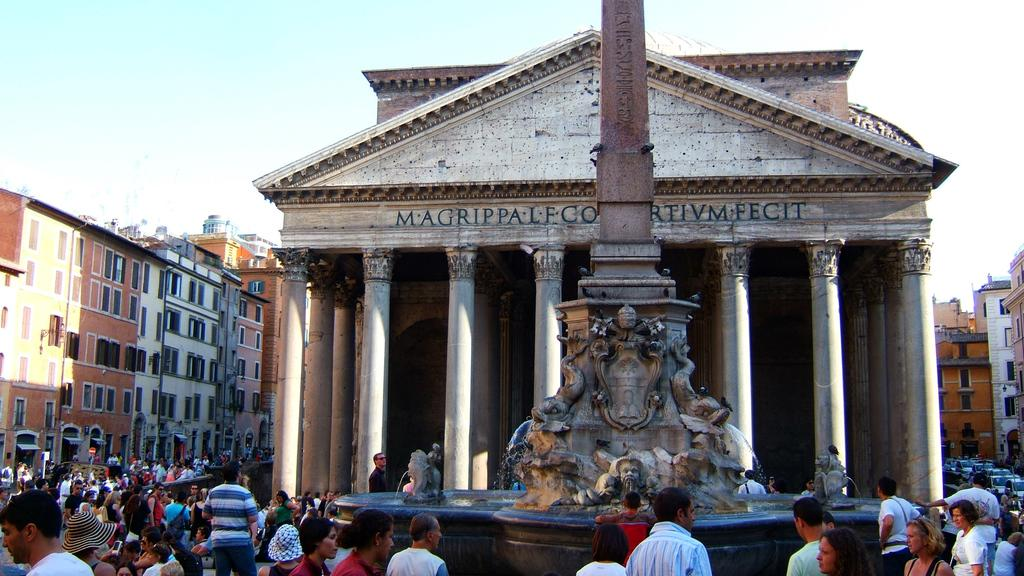What is the main feature in the middle of the image? There is a fountain in the center of the image. What can be seen in the distance behind the fountain? There are buildings in the background of the image. How many people are visible at the bottom side of the image? There are many people at the bottom side of the image. What type of paper is being used for the addition of numbers in the image? There is no paper or addition of numbers present in the image. 